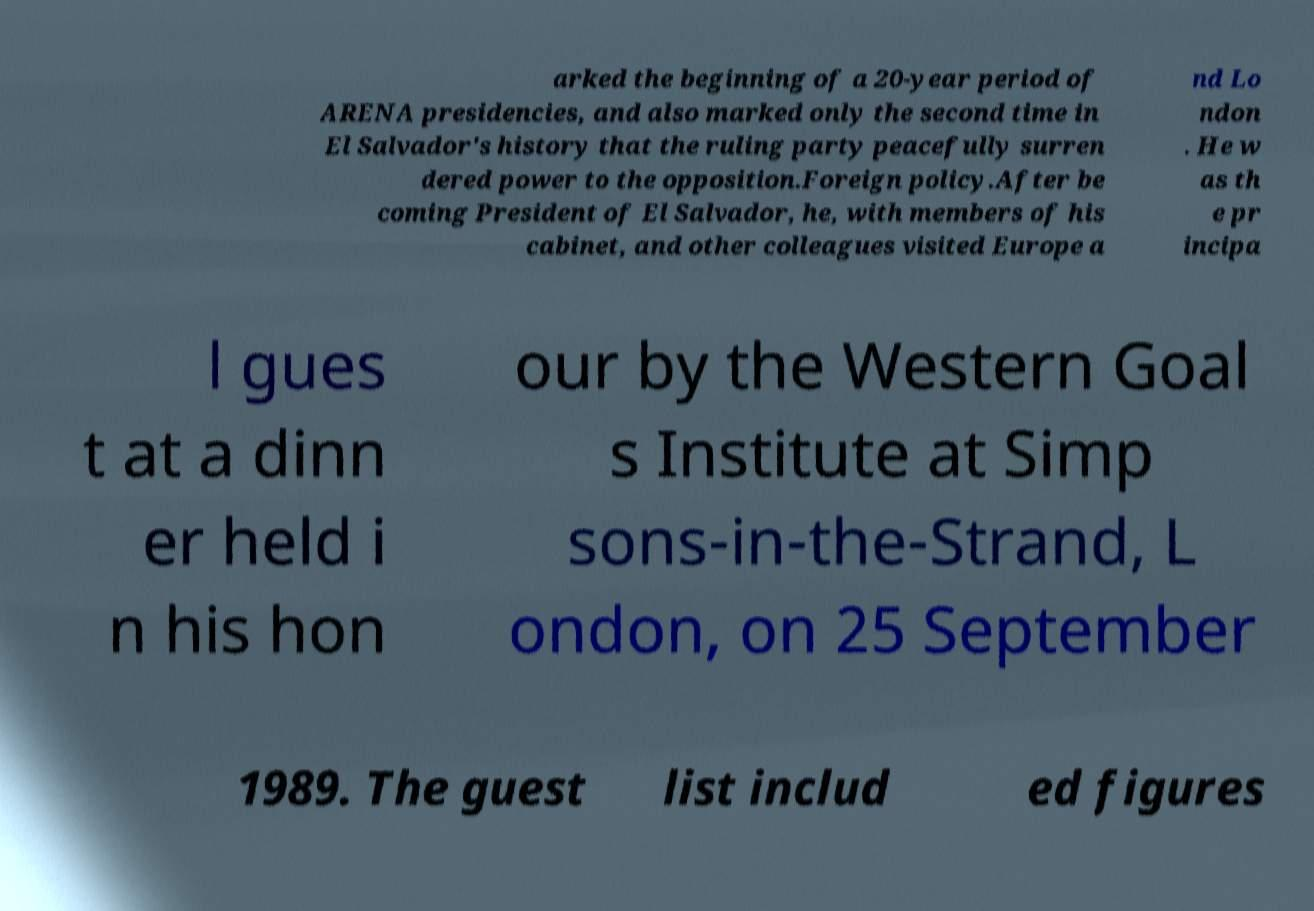Can you accurately transcribe the text from the provided image for me? arked the beginning of a 20-year period of ARENA presidencies, and also marked only the second time in El Salvador's history that the ruling party peacefully surren dered power to the opposition.Foreign policy.After be coming President of El Salvador, he, with members of his cabinet, and other colleagues visited Europe a nd Lo ndon . He w as th e pr incipa l gues t at a dinn er held i n his hon our by the Western Goal s Institute at Simp sons-in-the-Strand, L ondon, on 25 September 1989. The guest list includ ed figures 